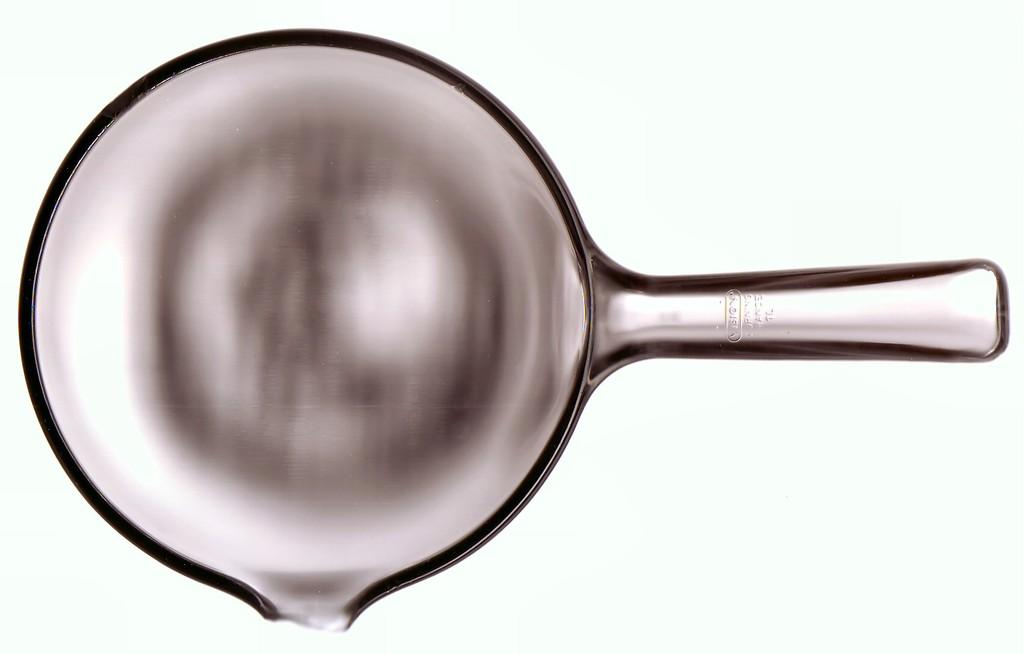What is the main object in the image? There is a pan in the image. What color is the background of the image? The background of the image is white. What type of skirt is hanging on the wall in the image? There is no skirt present in the image; it only features a pan and a white background. 